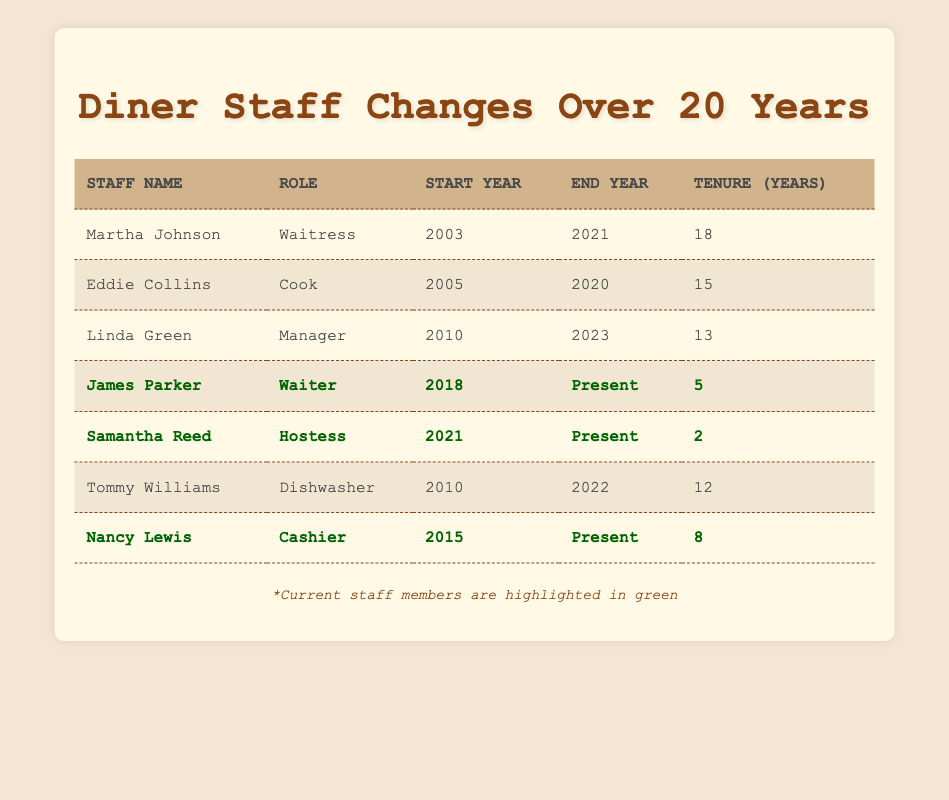What is the tenure of Martha Johnson? Martha Johnson's tenure is listed in the table under the "Tenure (Years)" column, which indicates she worked for 18 years from 2003 to 2021.
Answer: 18 Who worked as a Cook and when did they start? The table shows that Eddie Collins worked as a Cook and he started in 2005, as indicated in the "Role" and "Start Year" columns.
Answer: Eddie Collins, started in 2005 How many current staff members are there? The current staff members are indicated by their end year as "Present." Three staff members (James Parker, Samantha Reed, and Nancy Lewis) are currently employed based on the table.
Answer: 3 What is the average tenure of all the staff listed in the table? To find the average tenure, sum the tenures: 18 + 15 + 13 + 5 + 2 + 12 + 8 = 73. There are 7 staff members, so the average tenure is 73/7 = 10.43.
Answer: 10.43 Did any staff member work from 2021 onward? By examining the table, James Parker (Waiter), Samantha Reed (Hostess), and Nancy Lewis (Cashier) all have end years marked as “Present,” indicating they are working after 2021.
Answer: Yes Which role had the longest tenure? By analyzing the "Tenure (Years)” column, Martha Johnson worked the longest at 18 years as a Waitress, which is the highest tenure compared to others.
Answer: Waitress, 18 years How many staff members started working after 2015? The staff who started after 2015 are James Parker (2018), Samantha Reed (2021), and Nancy Lewis (2015). So, counting those, three started after 2015.
Answer: 3 What was the tenure of the Cook who stopped working in 2020? Eddie Collins is the Cook who ended his tenure in 2020, and his tenure lasted for 15 years, as reflected in the table.
Answer: 15 years What was the starting year for the Manager and how long did they work? The Manager, Linda Green, started in 2010 and worked until 2023, resulting in a tenure of 13 years, as represented in the table.
Answer: Started in 2010, worked for 13 years 